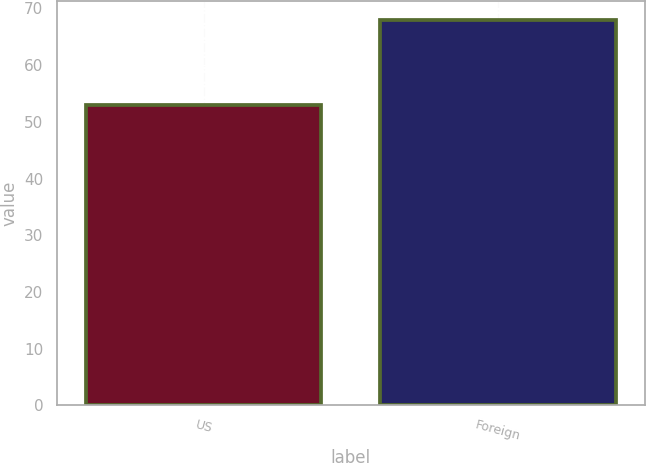Convert chart. <chart><loc_0><loc_0><loc_500><loc_500><bar_chart><fcel>US<fcel>Foreign<nl><fcel>53<fcel>68<nl></chart> 